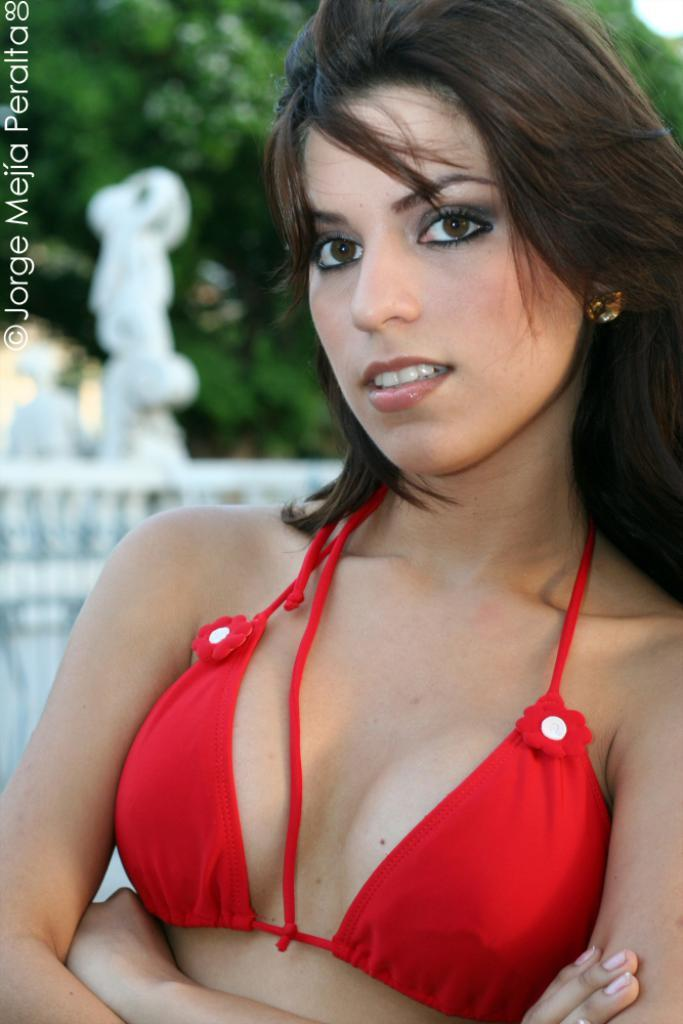Who is the main subject in the image? There is a woman in the image. What is the woman wearing? The woman is wearing a red dress. Can you describe the background of the image? The background of the image is slightly blurred, and there are trees and a wall visible. Is there any text in the image? Yes, there is edited text in the image. What type of creature is sitting on the woman's shoulder in the image? There is no creature present on the woman's shoulder in the image. How many drawers are visible in the image? There are no drawers visible in the image. 